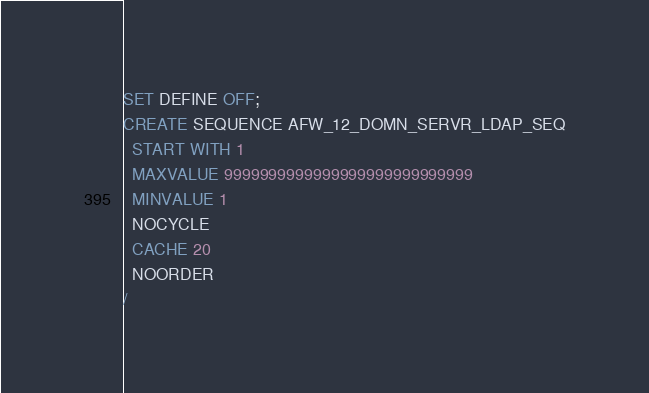<code> <loc_0><loc_0><loc_500><loc_500><_SQL_>SET DEFINE OFF;
CREATE SEQUENCE AFW_12_DOMN_SERVR_LDAP_SEQ
  START WITH 1
  MAXVALUE 9999999999999999999999999999
  MINVALUE 1
  NOCYCLE
  CACHE 20
  NOORDER
/
</code> 